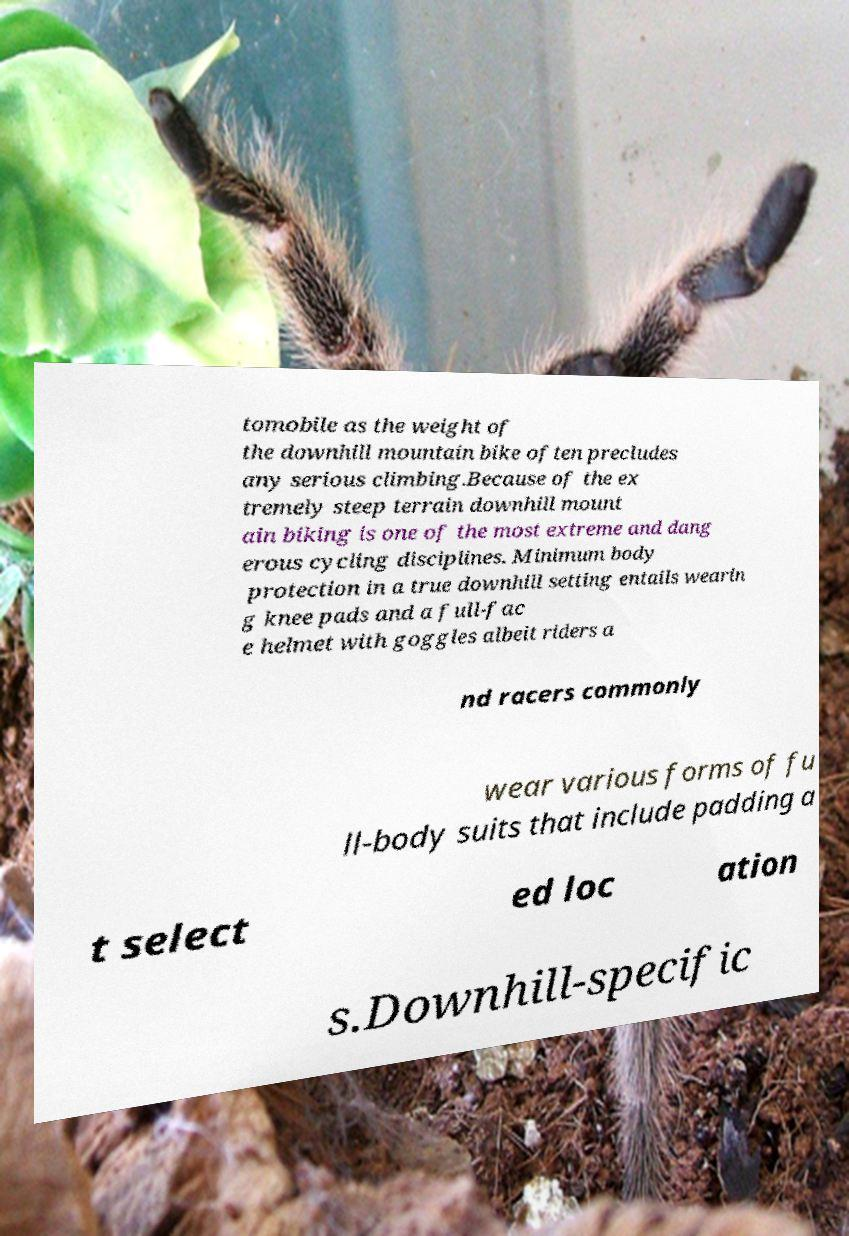What messages or text are displayed in this image? I need them in a readable, typed format. tomobile as the weight of the downhill mountain bike often precludes any serious climbing.Because of the ex tremely steep terrain downhill mount ain biking is one of the most extreme and dang erous cycling disciplines. Minimum body protection in a true downhill setting entails wearin g knee pads and a full-fac e helmet with goggles albeit riders a nd racers commonly wear various forms of fu ll-body suits that include padding a t select ed loc ation s.Downhill-specific 